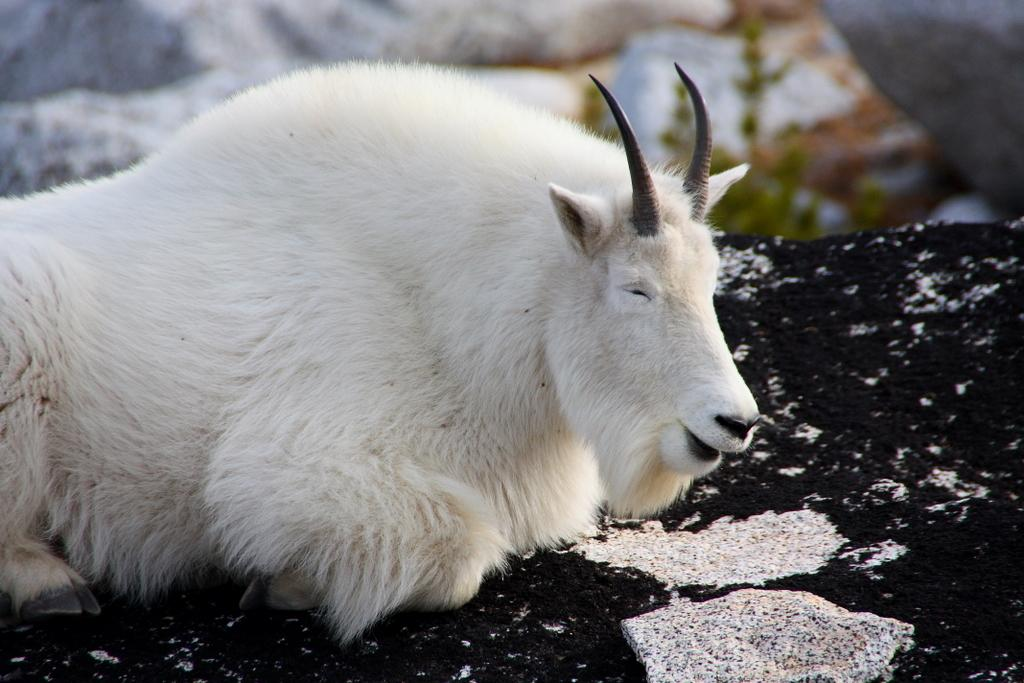What type of animal is in the image? There is a mountain goat in the image. What color is the mountain goat? The mountain goat is white in color. What other object can be seen in the image? There is a rock in the image. How would you describe the background of the image? The background of the image appears blurry. Is there any sleet visible in the image? There is no mention of sleet in the provided facts, and it does not appear in the image. Is the mountain goat reading a book in the image? There is no indication of the mountain goat engaging in any reading activity in the image. 